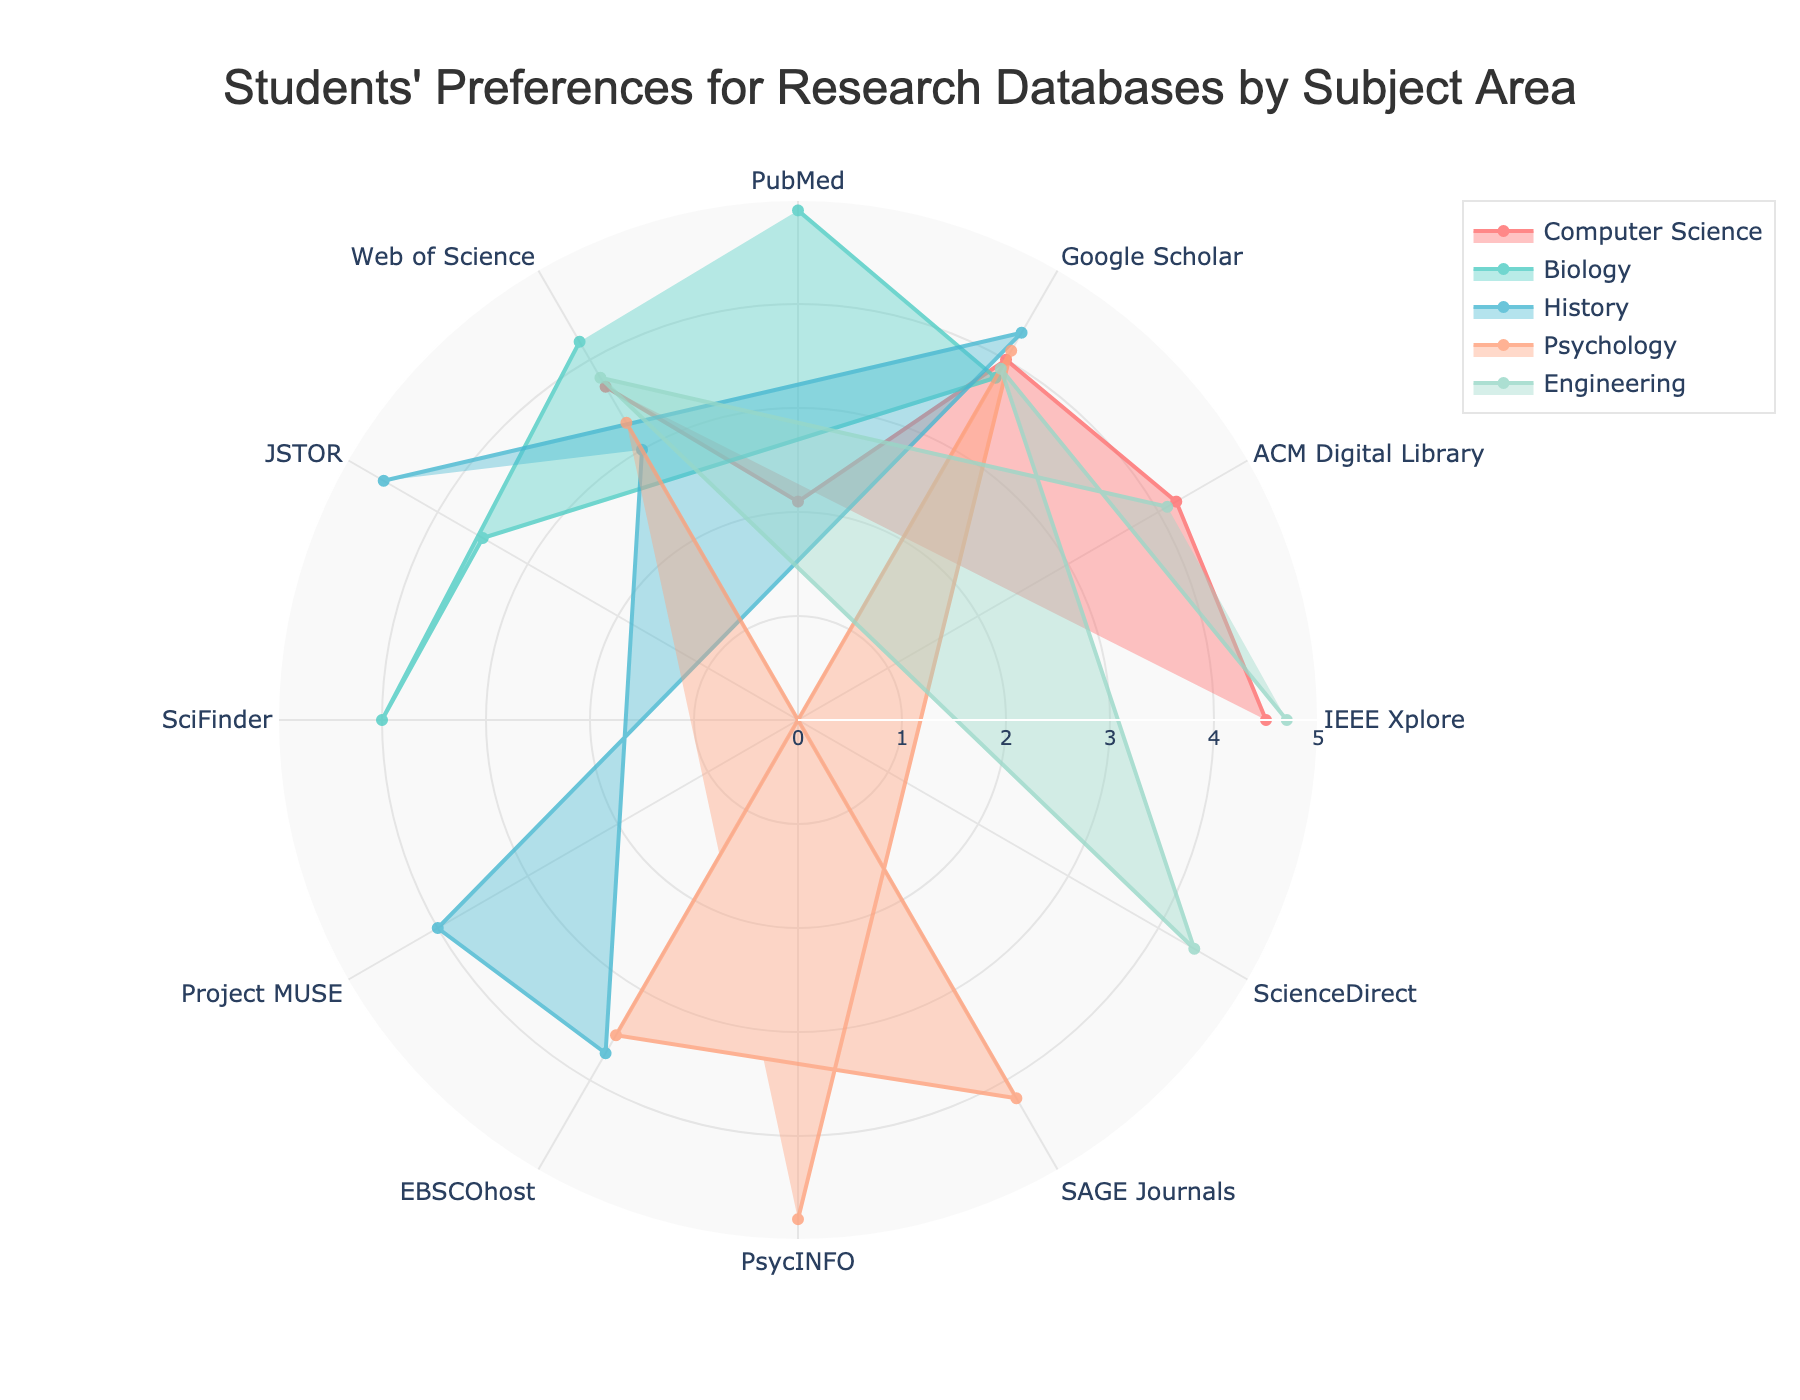What's the title of the figure? The title is usually the most prominent text element of the figure, typically shown at the top. In this figure, the title is clearly displayed.
Answer: Students' Preferences for Research Databases by Subject Area Which subject area uses “PubMed” most frequently? Identify the subject area with the highest value for “PubMed” by looking for the longest line on the radar chart under “PubMed” label.
Answer: Biology What is the average usage frequency of “Google Scholar” across all subjects? First, note the values of "Google Scholar" usage frequency for all subject areas: Computer Science (4.0), Biology (3.8), History (4.3), Psychology (4.1), Engineering (3.9). Sum these values (4.0 + 3.8 + 4.3 + 4.1 + 3.9 = 20.1), then divide by the number of subject areas (5). So, 20.1 / 5 = 4.02.
Answer: 4.02 Which database shows the highest average usage frequency across all subjects? Calculate the average usage frequency for each database across all subject areas, then compare these averages to determine the highest. IEEE Xplore (4.5 + 4.7)/2 = 4.6, ACM Digital Library (4.2 + 4.1)/2 = 4.15, Google Scholar (sum of 5 values/5) = 4.02, PubMed (4.9 + 2.1)/2 = 3.5, Web of Science (3.7 + 4.2 + 3.0 + 3.3 + 3.8)/5 = 3.6, JSTOR (4.6 + 3.5)/2 = 4.05. PsycINFO (4.8), Project MUSE (4.0), EBSCOhost (3.7 + 3.5)/2 = 3.6, SciFinder (4.0), SAGE Journals (4.2), ScienceDirect (4.4). IEEE Xplore has the highest average.
Answer: IEEE Xplore Which database is least preferred by Computer Science students? For Computer Science, locate the database with the lowest usage frequency. This will be the shortest distance from the center on the radar chart for Computer Science.
Answer: PubMed Which database is used by all subject areas? Identify the databases that appear in all subject areas on the radar chart.
Answer: Google Scholar, Web of Science What is the most preferred database for Psychology students? Identify the database with the highest usage frequency for Psychology by locating the longest line on the radar chart for Psychology.
Answer: PsycINFO 